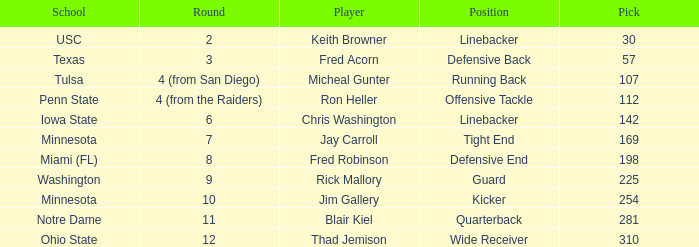What is the pick number of Penn State? 112.0. 